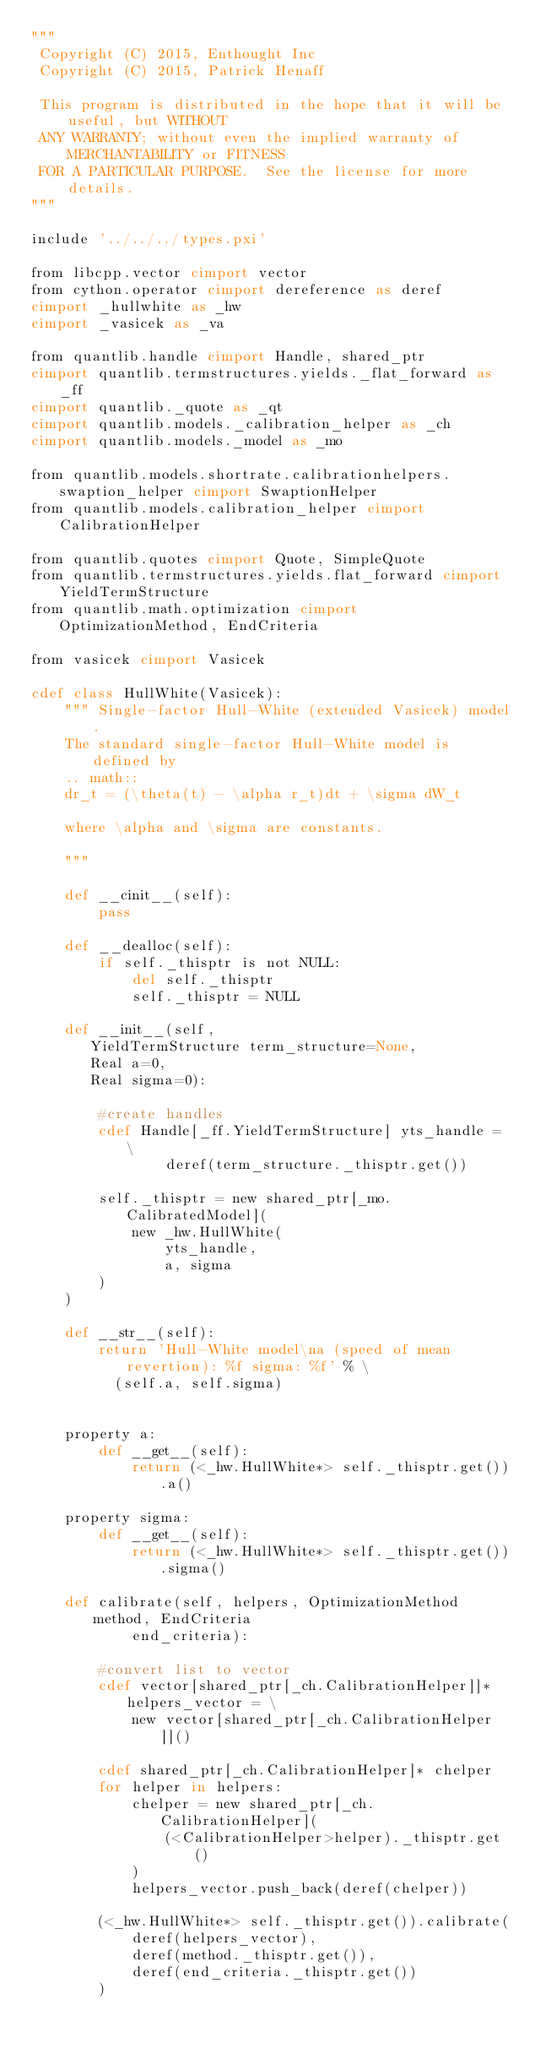Convert code to text. <code><loc_0><loc_0><loc_500><loc_500><_Cython_>"""
 Copyright (C) 2015, Enthought Inc
 Copyright (C) 2015, Patrick Henaff

 This program is distributed in the hope that it will be useful, but WITHOUT
 ANY WARRANTY; without even the implied warranty of MERCHANTABILITY or FITNESS
 FOR A PARTICULAR PURPOSE.  See the license for more details.
"""

include '../../../types.pxi'

from libcpp.vector cimport vector
from cython.operator cimport dereference as deref
cimport _hullwhite as _hw
cimport _vasicek as _va

from quantlib.handle cimport Handle, shared_ptr
cimport quantlib.termstructures.yields._flat_forward as _ff
cimport quantlib._quote as _qt
cimport quantlib.models._calibration_helper as _ch
cimport quantlib.models._model as _mo

from quantlib.models.shortrate.calibrationhelpers.swaption_helper cimport SwaptionHelper
from quantlib.models.calibration_helper cimport CalibrationHelper

from quantlib.quotes cimport Quote, SimpleQuote
from quantlib.termstructures.yields.flat_forward cimport YieldTermStructure
from quantlib.math.optimization cimport OptimizationMethod, EndCriteria

from vasicek cimport Vasicek

cdef class HullWhite(Vasicek):
    """ Single-factor Hull-White (extended Vasicek) model.
    The standard single-factor Hull-White model is defined by
    .. math::
    dr_t = (\theta(t) - \alpha r_t)dt + \sigma dW_t

    where \alpha and \sigma are constants.
    
    """

    def __cinit__(self):
        pass

    def __dealloc(self):
        if self._thisptr is not NULL:
            del self._thisptr
            self._thisptr = NULL

    def __init__(self,
       YieldTermStructure term_structure=None,
       Real a=0,
       Real sigma=0):

        #create handles
        cdef Handle[_ff.YieldTermStructure] yts_handle = \
                deref(term_structure._thisptr.get())

        self._thisptr = new shared_ptr[_mo.CalibratedModel](
            new _hw.HullWhite(
                yts_handle,
                a, sigma
	    )
	)

    def __str__(self):
        return 'Hull-White model\na (speed of mean revertion): %f sigma: %f' % \
          (self.a, self.sigma)


    property a:
        def __get__(self):
            return (<_hw.HullWhite*> self._thisptr.get()).a()

    property sigma:
        def __get__(self):
            return (<_hw.HullWhite*> self._thisptr.get()).sigma()

    def calibrate(self, helpers, OptimizationMethod method, EndCriteria
            end_criteria):

        #convert list to vector
        cdef vector[shared_ptr[_ch.CalibrationHelper]]* helpers_vector = \
            new vector[shared_ptr[_ch.CalibrationHelper]]()

        cdef shared_ptr[_ch.CalibrationHelper]* chelper
        for helper in helpers:
            chelper = new shared_ptr[_ch.CalibrationHelper](
                (<CalibrationHelper>helper)._thisptr.get()
            )
            helpers_vector.push_back(deref(chelper))

        (<_hw.HullWhite*> self._thisptr.get()).calibrate(
            deref(helpers_vector),
            deref(method._thisptr.get()),
            deref(end_criteria._thisptr.get())
        )
</code> 